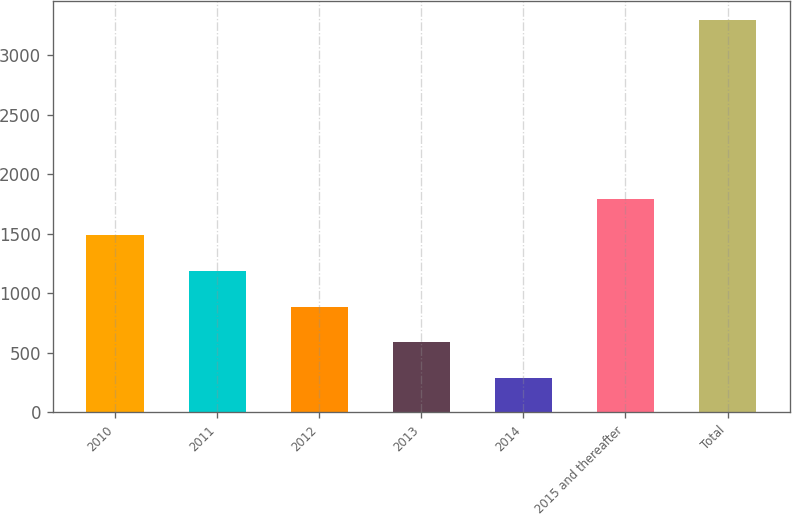Convert chart to OTSL. <chart><loc_0><loc_0><loc_500><loc_500><bar_chart><fcel>2010<fcel>2011<fcel>2012<fcel>2013<fcel>2014<fcel>2015 and thereafter<fcel>Total<nl><fcel>1489.92<fcel>1189.19<fcel>888.46<fcel>587.73<fcel>287<fcel>1790.65<fcel>3294.3<nl></chart> 